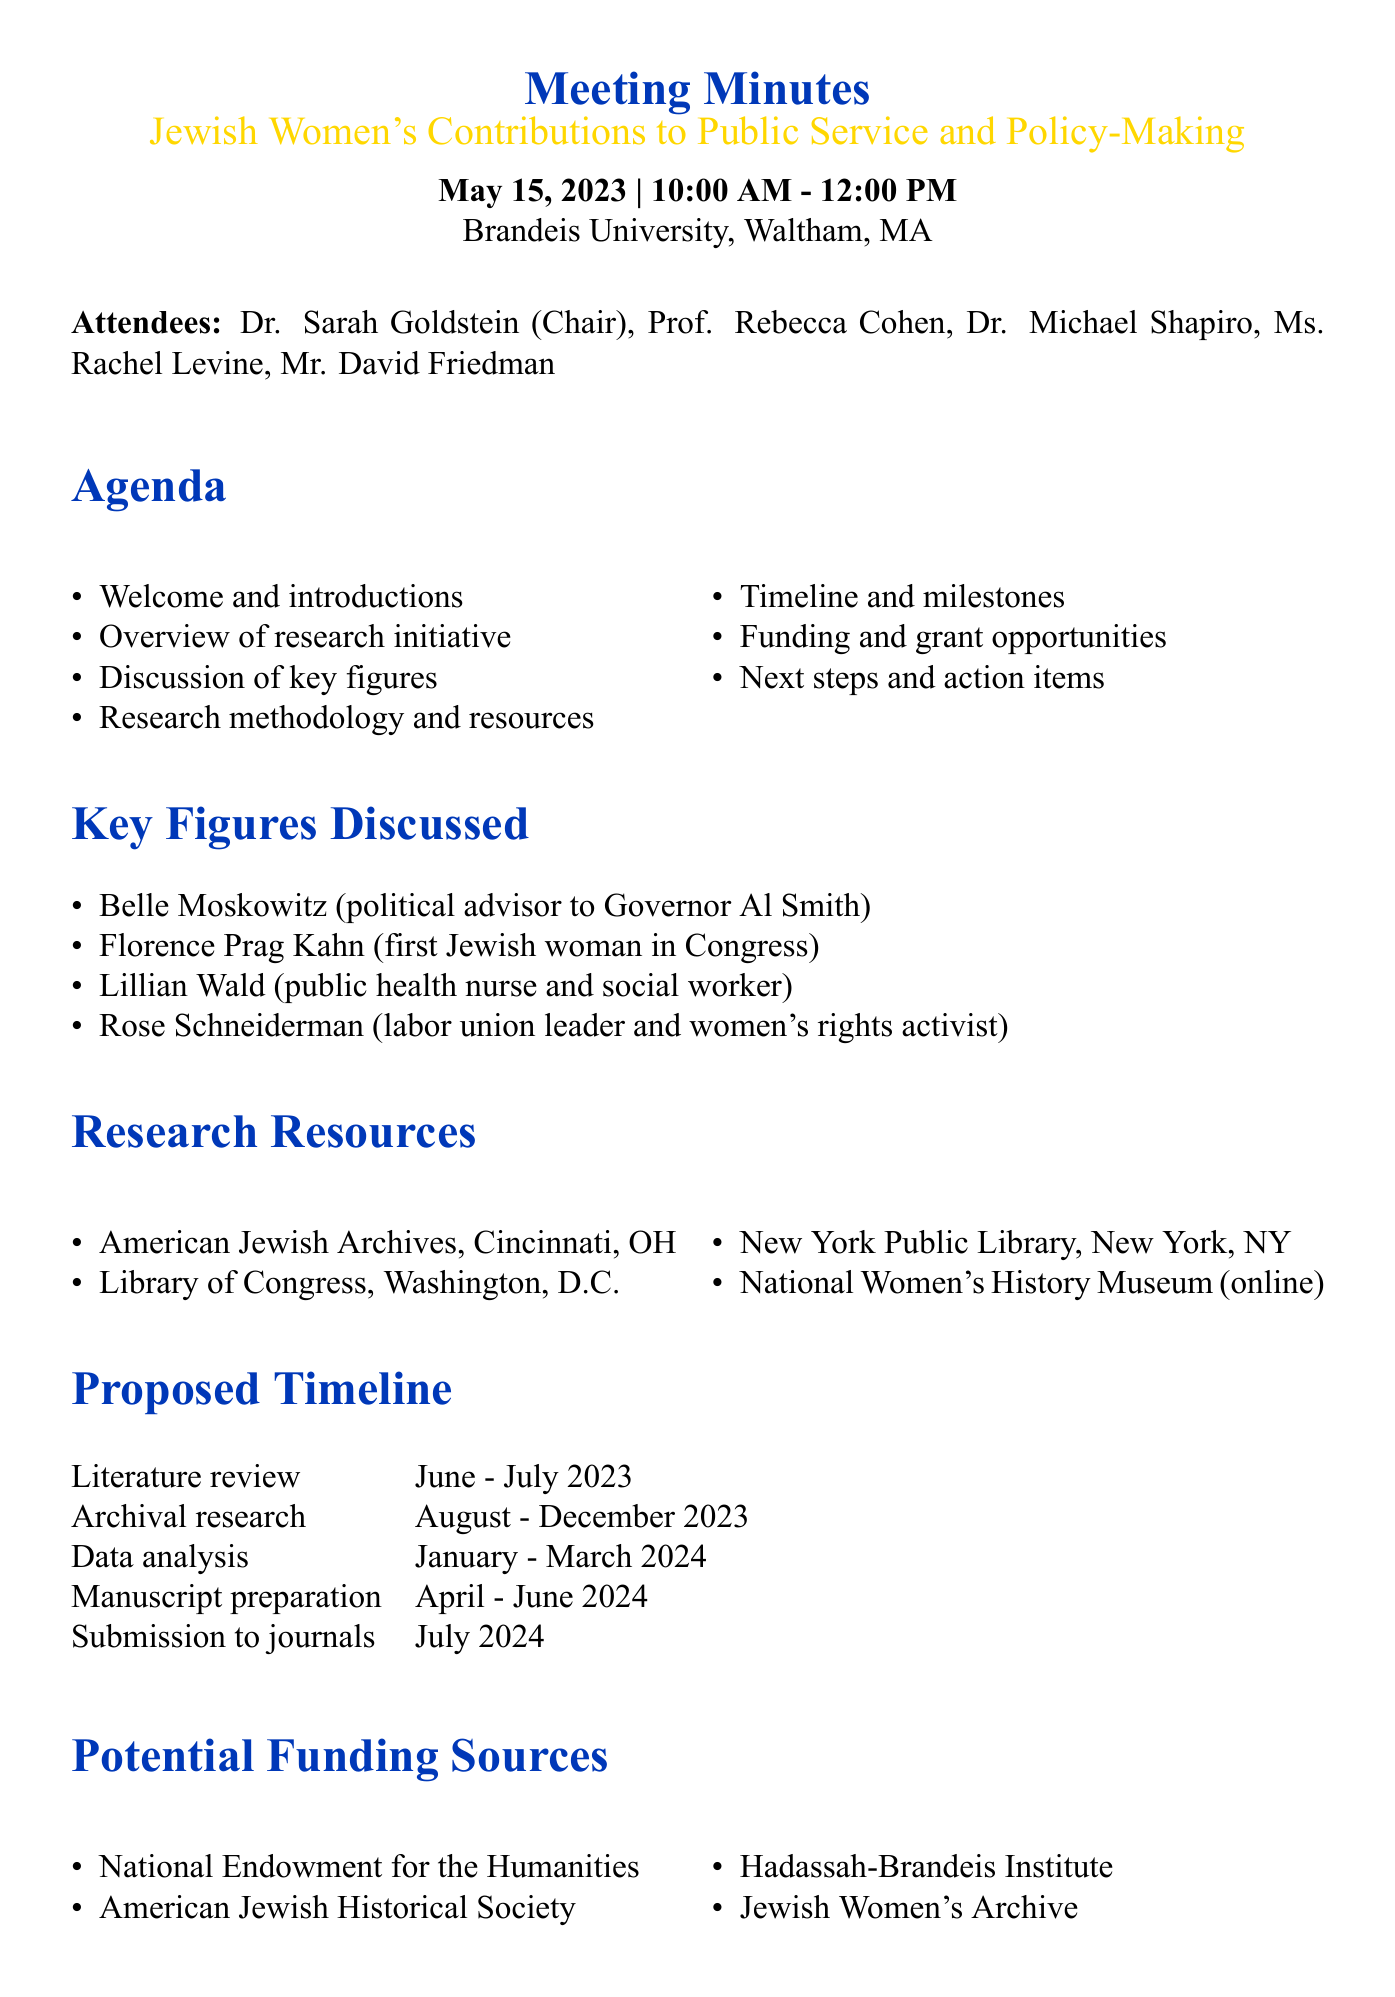What was the date of the meeting? The date of the meeting is specifically listed in the document as May 15, 2023.
Answer: May 15, 2023 Who chaired the meeting? The document specifies that Dr. Sarah Goldstein was the Chair of the meeting.
Answer: Dr. Sarah Goldstein What is the first key figure discussed in the meeting? The first key figure listed in the document is Belle Moskowitz.
Answer: Belle Moskowitz What is the proposed timeline for the literature review? The timeline for the literature review is included in a specific section and is noted as June - July 2023.
Answer: June - July 2023 Which funding source is mentioned first? The document lists potential funding sources, with the first being the National Endowment for the Humanities.
Answer: National Endowment for the Humanities What action item is assigned to Prof. Cohen? The action item for Prof. Cohen is detailed as compiling an initial bibliography by June 15.
Answer: Compile initial bibliography by June 15 What location hosted the meeting? The document mentions Brandeis University, Waltham, MA as the meeting location.
Answer: Brandeis University, Waltham, MA How many attendees were present at the meeting? According to the document, there are five attendees listed.
Answer: Five What is the key focus of the research initiative? The document indicates that the focus is on Jewish women's contributions to public service and policy-making in the early 20th century.
Answer: Jewish women's contributions to public service and policy-making in the early 20th century 